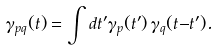Convert formula to latex. <formula><loc_0><loc_0><loc_500><loc_500>\gamma _ { p q } ( t ) = \int d t ^ { \prime } \gamma _ { p } ( t ^ { \prime } ) \, \gamma _ { q } ( t { - } t ^ { \prime } ) .</formula> 